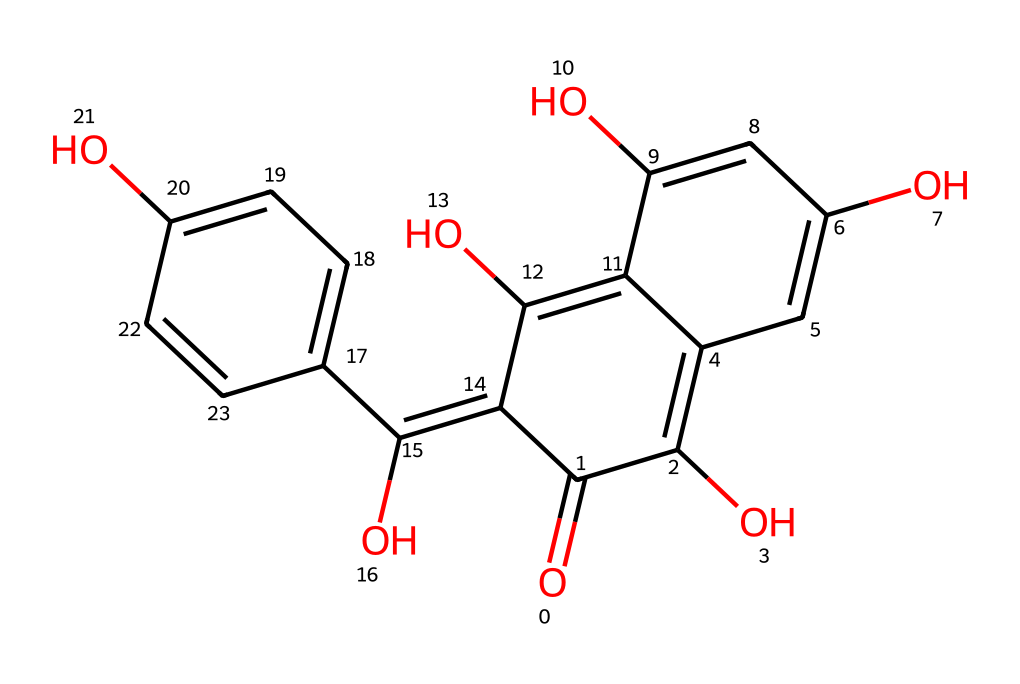What is the molecular formula of quercetin? To determine the molecular formula, we count the number of each type of atom in the provided structure. The SMILES indicates the presence of carbon (C), hydrogen (H), and oxygen (O) atoms. Counting gives us C15, H10, and O7. Therefore, the molecular formula is derived from these counts.
Answer: C15H10O7 How many hydroxyl (-OH) groups are present in the structure? By examining the structure visually or analyzing the SMILES representation, we can locate the hydroxyl groups, which are found where oxygen is bonded to hydrogen. In this molecule, there are five -OH groups present, indicating its antioxidant properties.
Answer: 5 What type of chemical compound is quercetin? Quercetin is classified as a flavonoid, which is a specific type of polyphenolic compound. The presence of multiple aromatic rings and hydroxyl groups identifies it as such. This classification is evident from its structure as well.
Answer: flavonoid What is the total number of rings in the quercetin structure? By scrutinizing the chemical structure and identifying where the rings close, we see that quercetin contains three distinct cyclic structures formed by the arrangement of carbon atoms. This is confirmed by analyzing how many cyclic connections are made in the structure.
Answer: 3 Which part of the quercetin structure contributes to its antioxidant activity? The antioxidant activity of quercetin is primarily attributed to the presence of its multiple hydroxyl groups (-OH). These groups are responsible for scavenging free radicals, which is a key function of antioxidants. Observing their locations reveals their role in the molecule.
Answer: hydroxyl groups 